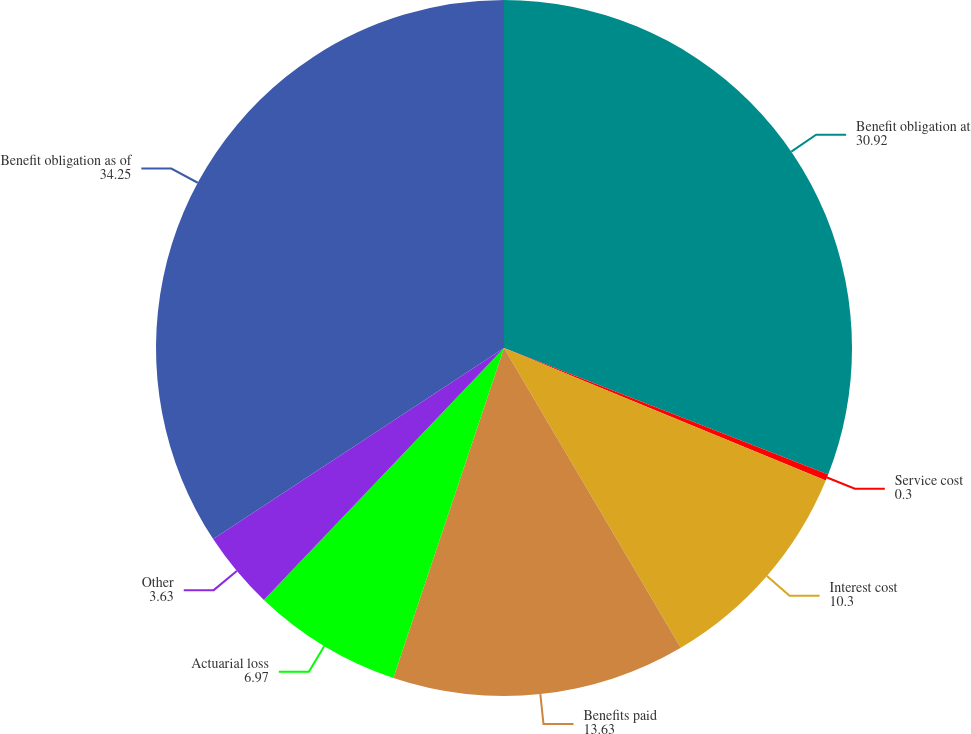<chart> <loc_0><loc_0><loc_500><loc_500><pie_chart><fcel>Benefit obligation at<fcel>Service cost<fcel>Interest cost<fcel>Benefits paid<fcel>Actuarial loss<fcel>Other<fcel>Benefit obligation as of<nl><fcel>30.92%<fcel>0.3%<fcel>10.3%<fcel>13.63%<fcel>6.97%<fcel>3.63%<fcel>34.25%<nl></chart> 